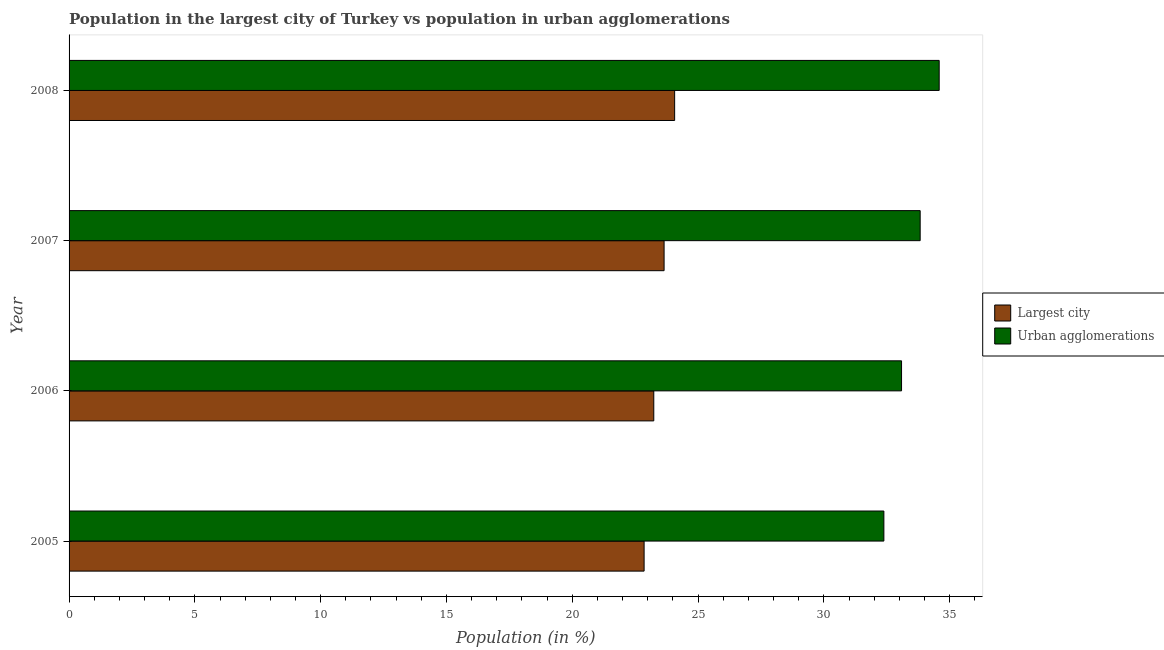How many different coloured bars are there?
Offer a very short reply. 2. How many groups of bars are there?
Make the answer very short. 4. In how many cases, is the number of bars for a given year not equal to the number of legend labels?
Keep it short and to the point. 0. What is the population in the largest city in 2005?
Offer a very short reply. 22.86. Across all years, what is the maximum population in urban agglomerations?
Your answer should be very brief. 34.58. Across all years, what is the minimum population in the largest city?
Your response must be concise. 22.86. What is the total population in urban agglomerations in the graph?
Make the answer very short. 133.89. What is the difference between the population in urban agglomerations in 2006 and that in 2007?
Your answer should be compact. -0.74. What is the difference between the population in urban agglomerations in 2006 and the population in the largest city in 2005?
Ensure brevity in your answer.  10.23. What is the average population in urban agglomerations per year?
Make the answer very short. 33.47. In the year 2005, what is the difference between the population in the largest city and population in urban agglomerations?
Make the answer very short. -9.53. Is the difference between the population in the largest city in 2005 and 2006 greater than the difference between the population in urban agglomerations in 2005 and 2006?
Keep it short and to the point. Yes. What is the difference between the highest and the second highest population in urban agglomerations?
Your answer should be very brief. 0.76. What is the difference between the highest and the lowest population in urban agglomerations?
Offer a terse response. 2.2. What does the 2nd bar from the top in 2005 represents?
Offer a very short reply. Largest city. What does the 2nd bar from the bottom in 2008 represents?
Provide a succinct answer. Urban agglomerations. How many years are there in the graph?
Give a very brief answer. 4. What is the difference between two consecutive major ticks on the X-axis?
Give a very brief answer. 5. Does the graph contain grids?
Provide a short and direct response. No. How many legend labels are there?
Provide a succinct answer. 2. What is the title of the graph?
Offer a very short reply. Population in the largest city of Turkey vs population in urban agglomerations. Does "Frequency of shipment arrival" appear as one of the legend labels in the graph?
Make the answer very short. No. What is the label or title of the X-axis?
Your response must be concise. Population (in %). What is the label or title of the Y-axis?
Give a very brief answer. Year. What is the Population (in %) of Largest city in 2005?
Your answer should be very brief. 22.86. What is the Population (in %) of Urban agglomerations in 2005?
Ensure brevity in your answer.  32.39. What is the Population (in %) in Largest city in 2006?
Keep it short and to the point. 23.24. What is the Population (in %) in Urban agglomerations in 2006?
Make the answer very short. 33.09. What is the Population (in %) of Largest city in 2007?
Give a very brief answer. 23.65. What is the Population (in %) in Urban agglomerations in 2007?
Offer a terse response. 33.83. What is the Population (in %) in Largest city in 2008?
Provide a succinct answer. 24.07. What is the Population (in %) in Urban agglomerations in 2008?
Offer a terse response. 34.58. Across all years, what is the maximum Population (in %) in Largest city?
Your answer should be compact. 24.07. Across all years, what is the maximum Population (in %) of Urban agglomerations?
Give a very brief answer. 34.58. Across all years, what is the minimum Population (in %) in Largest city?
Give a very brief answer. 22.86. Across all years, what is the minimum Population (in %) of Urban agglomerations?
Offer a terse response. 32.39. What is the total Population (in %) of Largest city in the graph?
Provide a short and direct response. 93.82. What is the total Population (in %) of Urban agglomerations in the graph?
Your answer should be compact. 133.89. What is the difference between the Population (in %) of Largest city in 2005 and that in 2006?
Your response must be concise. -0.38. What is the difference between the Population (in %) in Urban agglomerations in 2005 and that in 2006?
Make the answer very short. -0.7. What is the difference between the Population (in %) in Largest city in 2005 and that in 2007?
Give a very brief answer. -0.79. What is the difference between the Population (in %) of Urban agglomerations in 2005 and that in 2007?
Provide a succinct answer. -1.44. What is the difference between the Population (in %) of Largest city in 2005 and that in 2008?
Provide a short and direct response. -1.21. What is the difference between the Population (in %) of Urban agglomerations in 2005 and that in 2008?
Your answer should be compact. -2.2. What is the difference between the Population (in %) of Largest city in 2006 and that in 2007?
Your answer should be very brief. -0.41. What is the difference between the Population (in %) of Urban agglomerations in 2006 and that in 2007?
Provide a short and direct response. -0.74. What is the difference between the Population (in %) of Largest city in 2006 and that in 2008?
Provide a succinct answer. -0.83. What is the difference between the Population (in %) of Urban agglomerations in 2006 and that in 2008?
Offer a very short reply. -1.5. What is the difference between the Population (in %) of Largest city in 2007 and that in 2008?
Keep it short and to the point. -0.42. What is the difference between the Population (in %) of Urban agglomerations in 2007 and that in 2008?
Ensure brevity in your answer.  -0.76. What is the difference between the Population (in %) of Largest city in 2005 and the Population (in %) of Urban agglomerations in 2006?
Your answer should be compact. -10.23. What is the difference between the Population (in %) of Largest city in 2005 and the Population (in %) of Urban agglomerations in 2007?
Your response must be concise. -10.97. What is the difference between the Population (in %) of Largest city in 2005 and the Population (in %) of Urban agglomerations in 2008?
Your response must be concise. -11.73. What is the difference between the Population (in %) of Largest city in 2006 and the Population (in %) of Urban agglomerations in 2007?
Give a very brief answer. -10.59. What is the difference between the Population (in %) in Largest city in 2006 and the Population (in %) in Urban agglomerations in 2008?
Offer a very short reply. -11.34. What is the difference between the Population (in %) in Largest city in 2007 and the Population (in %) in Urban agglomerations in 2008?
Provide a short and direct response. -10.93. What is the average Population (in %) of Largest city per year?
Offer a terse response. 23.45. What is the average Population (in %) in Urban agglomerations per year?
Your answer should be very brief. 33.47. In the year 2005, what is the difference between the Population (in %) in Largest city and Population (in %) in Urban agglomerations?
Your answer should be compact. -9.53. In the year 2006, what is the difference between the Population (in %) of Largest city and Population (in %) of Urban agglomerations?
Your answer should be compact. -9.85. In the year 2007, what is the difference between the Population (in %) in Largest city and Population (in %) in Urban agglomerations?
Provide a succinct answer. -10.18. In the year 2008, what is the difference between the Population (in %) of Largest city and Population (in %) of Urban agglomerations?
Provide a short and direct response. -10.52. What is the ratio of the Population (in %) of Largest city in 2005 to that in 2006?
Provide a short and direct response. 0.98. What is the ratio of the Population (in %) of Urban agglomerations in 2005 to that in 2006?
Your answer should be compact. 0.98. What is the ratio of the Population (in %) of Largest city in 2005 to that in 2007?
Ensure brevity in your answer.  0.97. What is the ratio of the Population (in %) of Urban agglomerations in 2005 to that in 2007?
Your answer should be very brief. 0.96. What is the ratio of the Population (in %) in Largest city in 2005 to that in 2008?
Offer a very short reply. 0.95. What is the ratio of the Population (in %) of Urban agglomerations in 2005 to that in 2008?
Provide a succinct answer. 0.94. What is the ratio of the Population (in %) of Largest city in 2006 to that in 2007?
Keep it short and to the point. 0.98. What is the ratio of the Population (in %) of Urban agglomerations in 2006 to that in 2007?
Make the answer very short. 0.98. What is the ratio of the Population (in %) of Largest city in 2006 to that in 2008?
Provide a succinct answer. 0.97. What is the ratio of the Population (in %) of Urban agglomerations in 2006 to that in 2008?
Keep it short and to the point. 0.96. What is the ratio of the Population (in %) of Largest city in 2007 to that in 2008?
Make the answer very short. 0.98. What is the ratio of the Population (in %) in Urban agglomerations in 2007 to that in 2008?
Ensure brevity in your answer.  0.98. What is the difference between the highest and the second highest Population (in %) of Largest city?
Your response must be concise. 0.42. What is the difference between the highest and the second highest Population (in %) of Urban agglomerations?
Ensure brevity in your answer.  0.76. What is the difference between the highest and the lowest Population (in %) of Largest city?
Keep it short and to the point. 1.21. What is the difference between the highest and the lowest Population (in %) of Urban agglomerations?
Provide a succinct answer. 2.2. 